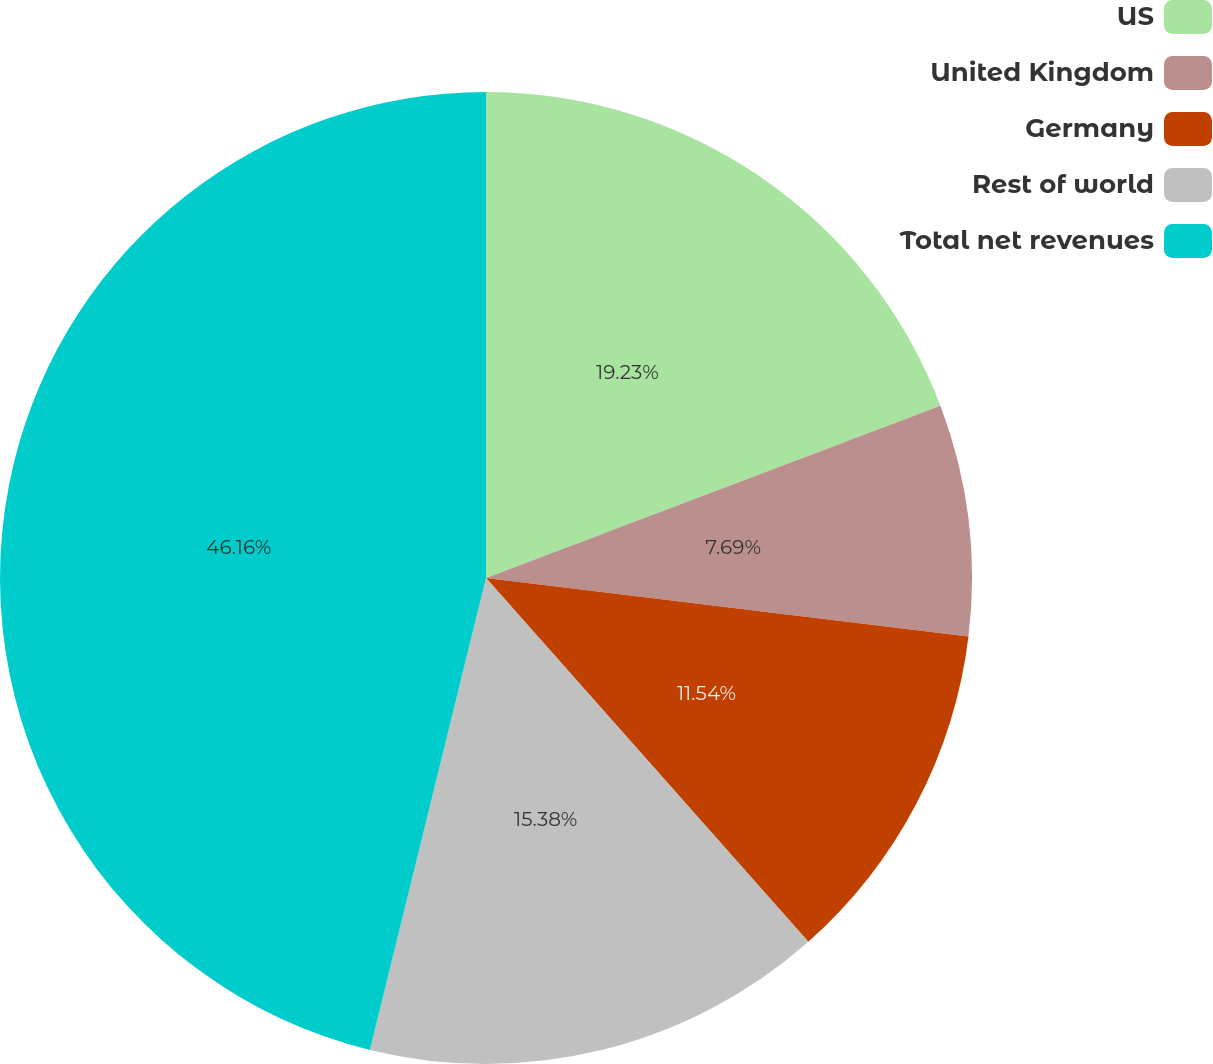Convert chart. <chart><loc_0><loc_0><loc_500><loc_500><pie_chart><fcel>US<fcel>United Kingdom<fcel>Germany<fcel>Rest of world<fcel>Total net revenues<nl><fcel>19.23%<fcel>7.69%<fcel>11.54%<fcel>15.38%<fcel>46.16%<nl></chart> 